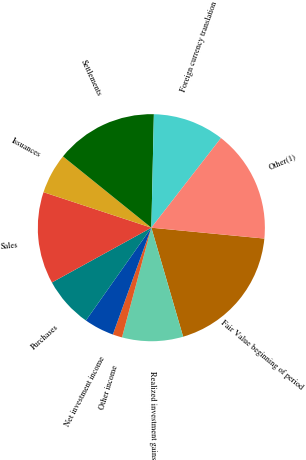Convert chart to OTSL. <chart><loc_0><loc_0><loc_500><loc_500><pie_chart><fcel>Fair Value beginning of period<fcel>Realized investment gains<fcel>Other income<fcel>Net investment income<fcel>Purchases<fcel>Sales<fcel>Issuances<fcel>Settlements<fcel>Foreign currency translation<fcel>Other(1)<nl><fcel>18.96%<fcel>8.68%<fcel>1.34%<fcel>4.27%<fcel>7.21%<fcel>13.08%<fcel>5.74%<fcel>14.55%<fcel>10.15%<fcel>16.02%<nl></chart> 